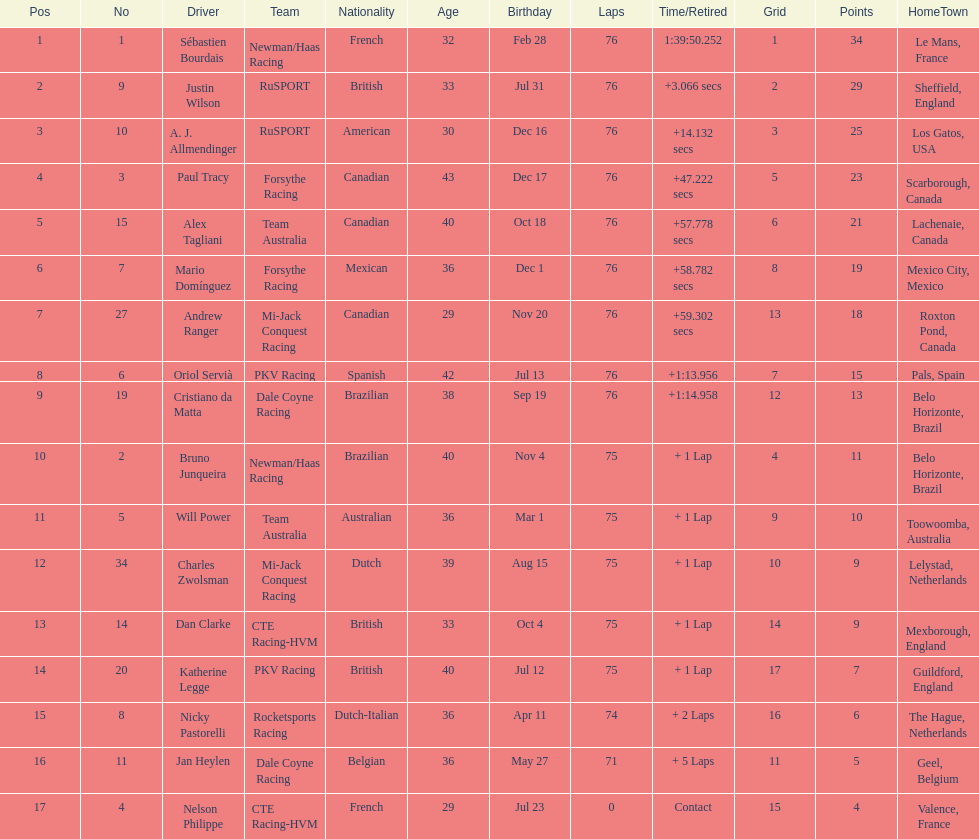Who is the driver with the most points earned? Sebastien Bourdais. 